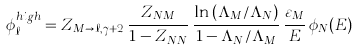Convert formula to latex. <formula><loc_0><loc_0><loc_500><loc_500>\phi _ { \ell } ^ { h i g h } = Z _ { M \to \ell , \gamma + 2 } \, \frac { Z _ { N M } } { 1 - Z _ { N N } } \, \frac { \ln \left ( { \Lambda _ { M } } / { \Lambda _ { N } } \right ) } { 1 - \Lambda _ { N } / \Lambda _ { M } } \, \frac { \varepsilon _ { M } } { E } \, \phi _ { N } ( E )</formula> 